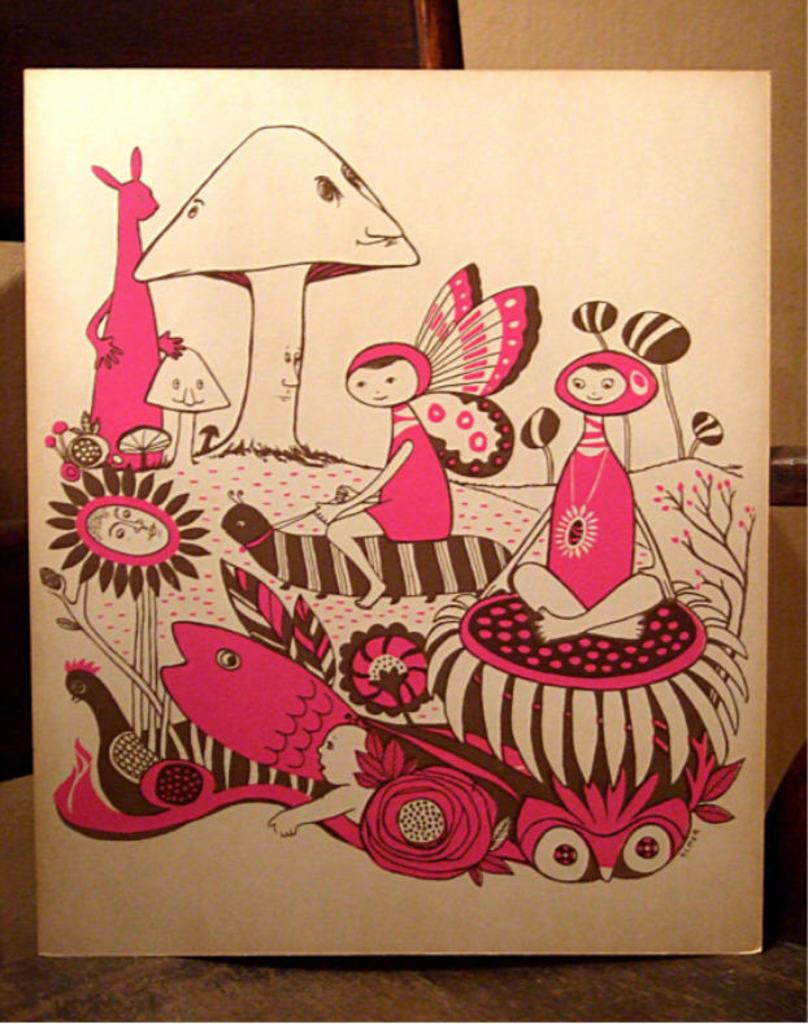What is depicted on the wooden board in the image? There are drawings on the wooden board in the image. What can be seen in the background of the image? There is a wall in the background of the image. What type of music is the band playing in the image? There is no band or music present in the image; it features a wooden board with drawings and a wall in the background. 